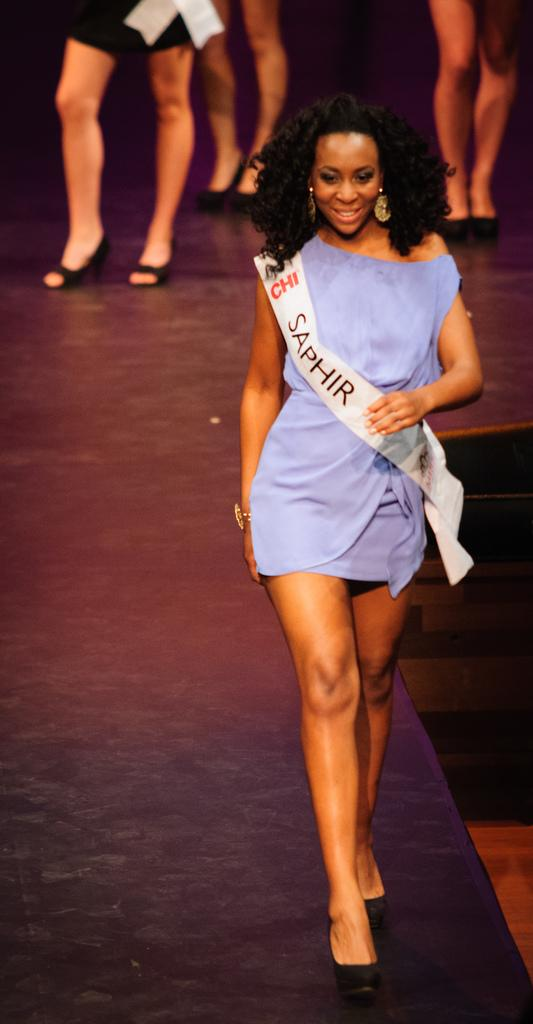Provide a one-sentence caption for the provided image. Lady walking on a runway with a banner across her that has SAPHIR in black letters. 